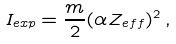<formula> <loc_0><loc_0><loc_500><loc_500>I _ { e x p } = \frac { m } { 2 } ( \alpha Z _ { e f f } ) ^ { 2 } \, ,</formula> 